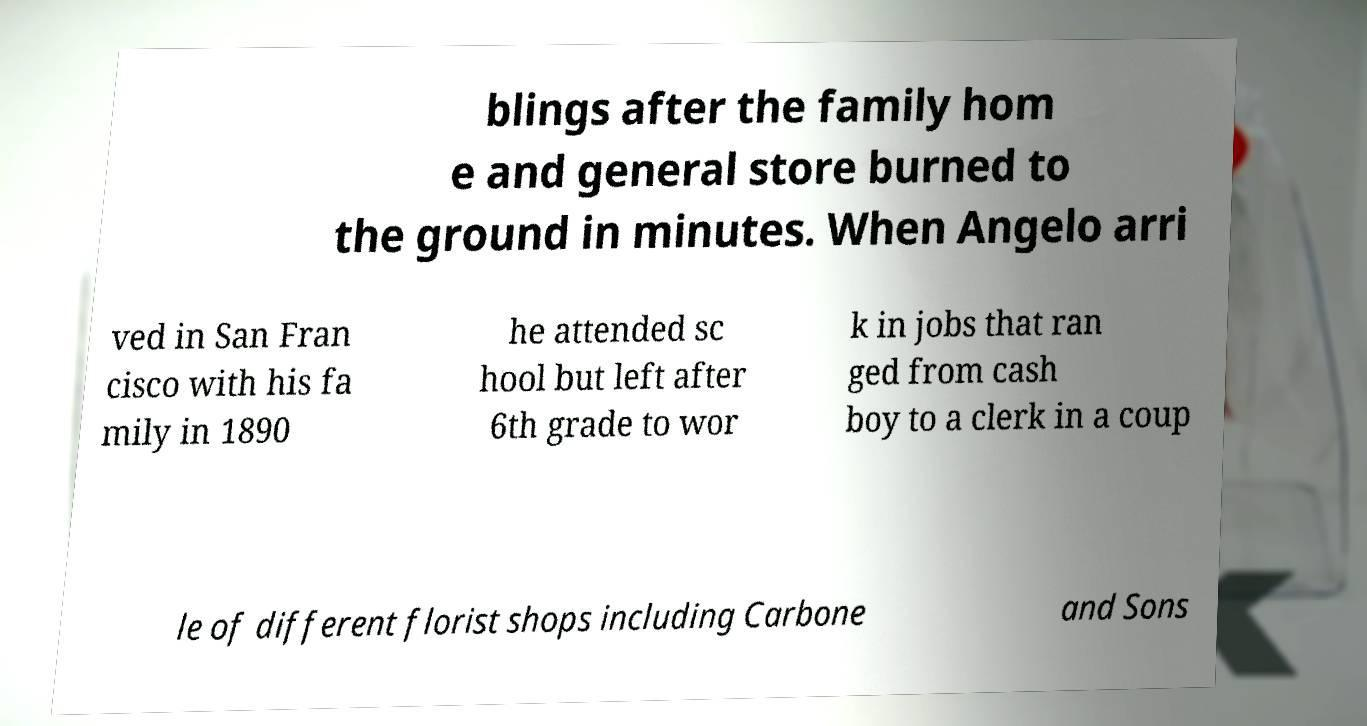There's text embedded in this image that I need extracted. Can you transcribe it verbatim? blings after the family hom e and general store burned to the ground in minutes. When Angelo arri ved in San Fran cisco with his fa mily in 1890 he attended sc hool but left after 6th grade to wor k in jobs that ran ged from cash boy to a clerk in a coup le of different florist shops including Carbone and Sons 